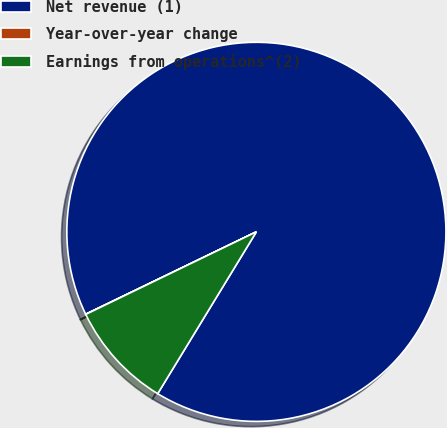<chart> <loc_0><loc_0><loc_500><loc_500><pie_chart><fcel>Net revenue (1)<fcel>Year-over-year change<fcel>Earnings from operations^(2)<nl><fcel>90.87%<fcel>0.02%<fcel>9.11%<nl></chart> 